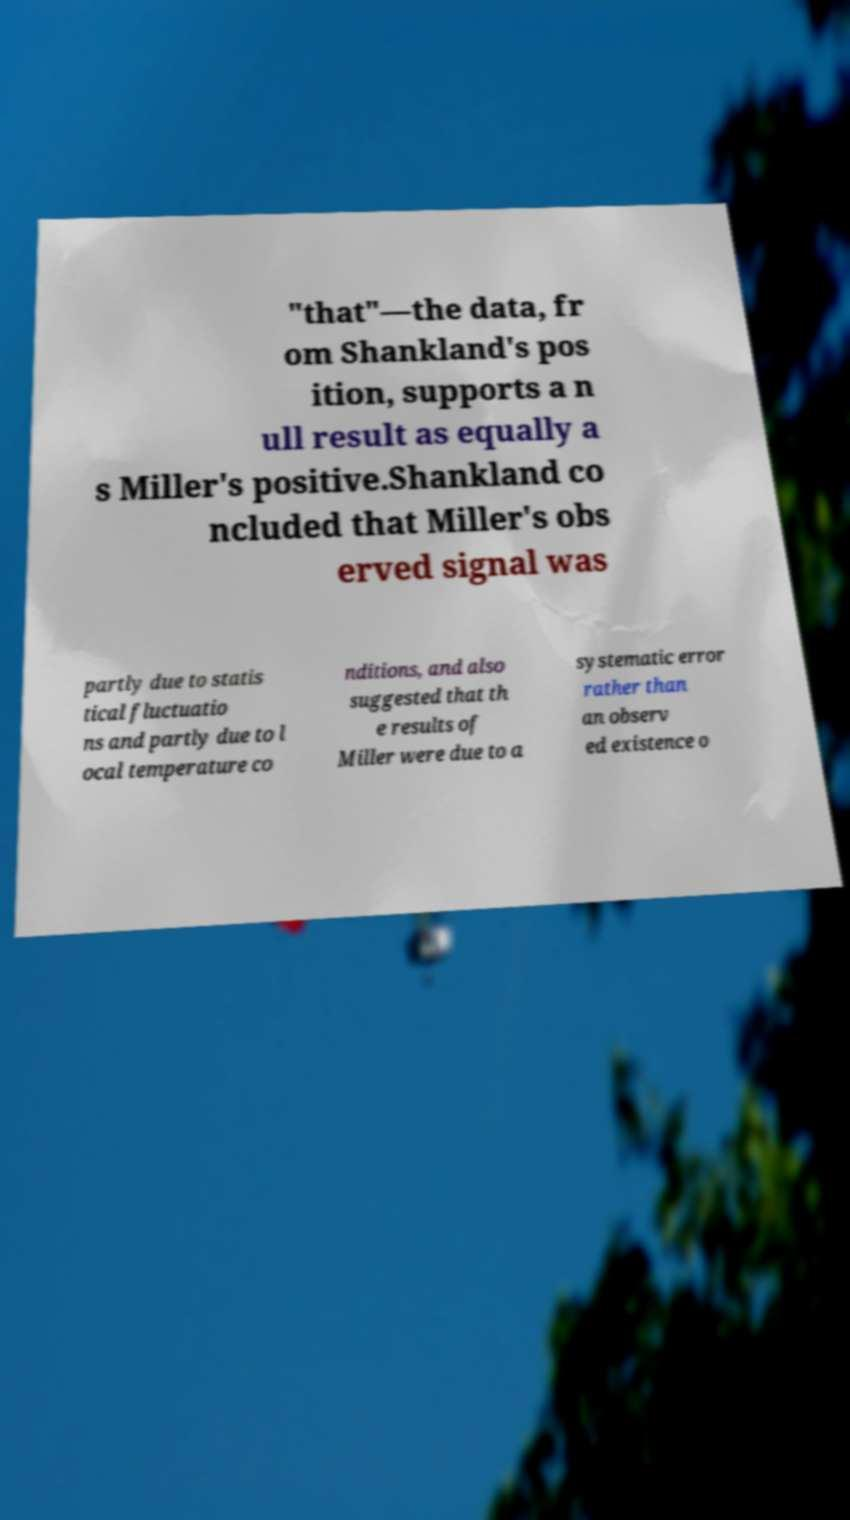Please identify and transcribe the text found in this image. "that"—the data, fr om Shankland's pos ition, supports a n ull result as equally a s Miller's positive.Shankland co ncluded that Miller's obs erved signal was partly due to statis tical fluctuatio ns and partly due to l ocal temperature co nditions, and also suggested that th e results of Miller were due to a systematic error rather than an observ ed existence o 